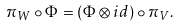Convert formula to latex. <formula><loc_0><loc_0><loc_500><loc_500>\pi _ { W } \circ \Phi = ( \Phi \otimes i d ) \circ \pi _ { V } .</formula> 